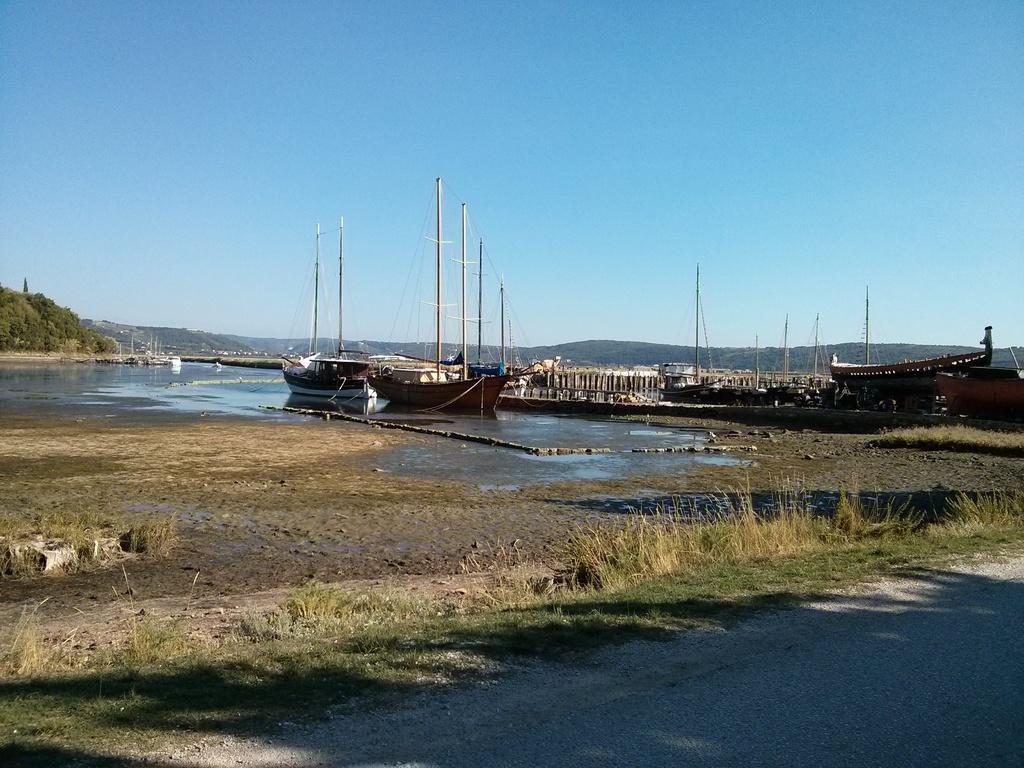Describe this image in one or two sentences. In this picture we can see grass on the ground and in the background we can see water, boats, trees and the sky. 